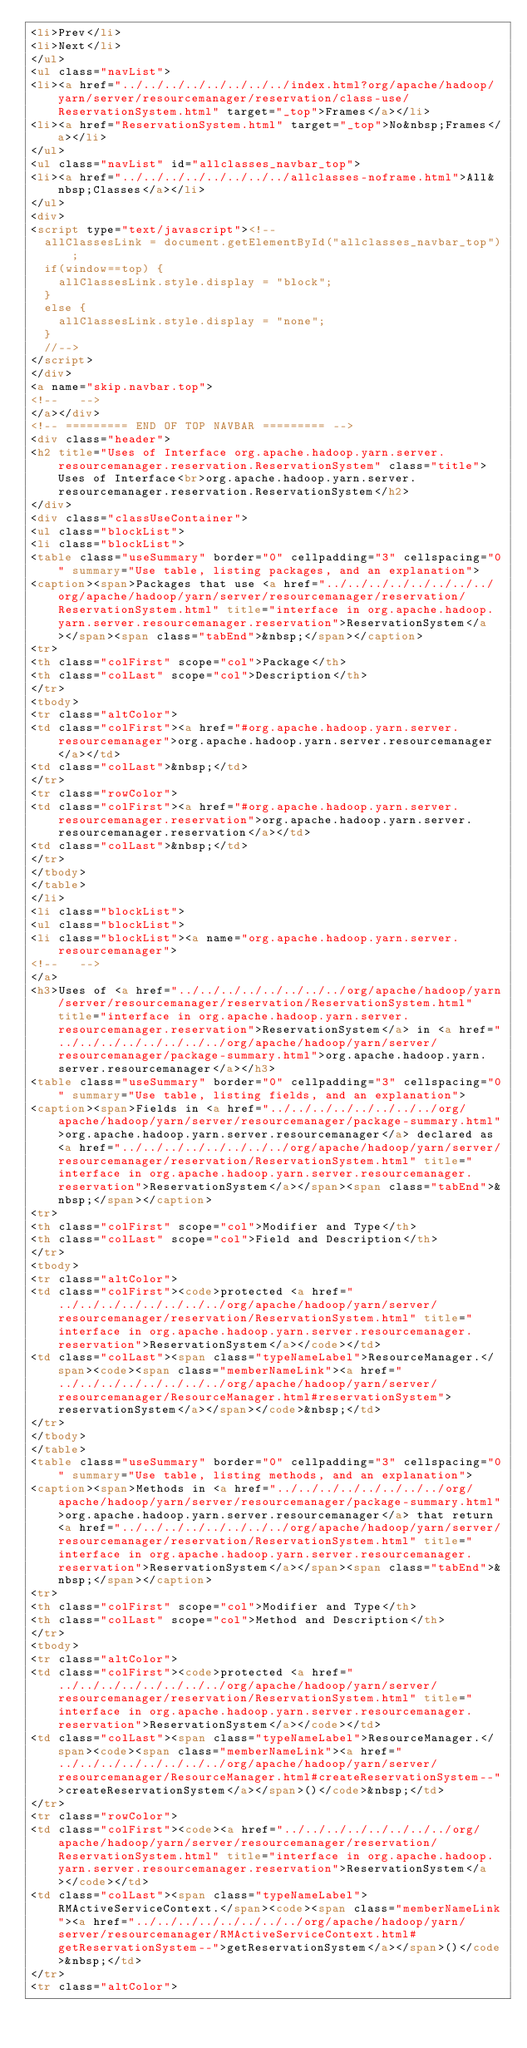<code> <loc_0><loc_0><loc_500><loc_500><_HTML_><li>Prev</li>
<li>Next</li>
</ul>
<ul class="navList">
<li><a href="../../../../../../../../index.html?org/apache/hadoop/yarn/server/resourcemanager/reservation/class-use/ReservationSystem.html" target="_top">Frames</a></li>
<li><a href="ReservationSystem.html" target="_top">No&nbsp;Frames</a></li>
</ul>
<ul class="navList" id="allclasses_navbar_top">
<li><a href="../../../../../../../../allclasses-noframe.html">All&nbsp;Classes</a></li>
</ul>
<div>
<script type="text/javascript"><!--
  allClassesLink = document.getElementById("allclasses_navbar_top");
  if(window==top) {
    allClassesLink.style.display = "block";
  }
  else {
    allClassesLink.style.display = "none";
  }
  //-->
</script>
</div>
<a name="skip.navbar.top">
<!--   -->
</a></div>
<!-- ========= END OF TOP NAVBAR ========= -->
<div class="header">
<h2 title="Uses of Interface org.apache.hadoop.yarn.server.resourcemanager.reservation.ReservationSystem" class="title">Uses of Interface<br>org.apache.hadoop.yarn.server.resourcemanager.reservation.ReservationSystem</h2>
</div>
<div class="classUseContainer">
<ul class="blockList">
<li class="blockList">
<table class="useSummary" border="0" cellpadding="3" cellspacing="0" summary="Use table, listing packages, and an explanation">
<caption><span>Packages that use <a href="../../../../../../../../org/apache/hadoop/yarn/server/resourcemanager/reservation/ReservationSystem.html" title="interface in org.apache.hadoop.yarn.server.resourcemanager.reservation">ReservationSystem</a></span><span class="tabEnd">&nbsp;</span></caption>
<tr>
<th class="colFirst" scope="col">Package</th>
<th class="colLast" scope="col">Description</th>
</tr>
<tbody>
<tr class="altColor">
<td class="colFirst"><a href="#org.apache.hadoop.yarn.server.resourcemanager">org.apache.hadoop.yarn.server.resourcemanager</a></td>
<td class="colLast">&nbsp;</td>
</tr>
<tr class="rowColor">
<td class="colFirst"><a href="#org.apache.hadoop.yarn.server.resourcemanager.reservation">org.apache.hadoop.yarn.server.resourcemanager.reservation</a></td>
<td class="colLast">&nbsp;</td>
</tr>
</tbody>
</table>
</li>
<li class="blockList">
<ul class="blockList">
<li class="blockList"><a name="org.apache.hadoop.yarn.server.resourcemanager">
<!--   -->
</a>
<h3>Uses of <a href="../../../../../../../../org/apache/hadoop/yarn/server/resourcemanager/reservation/ReservationSystem.html" title="interface in org.apache.hadoop.yarn.server.resourcemanager.reservation">ReservationSystem</a> in <a href="../../../../../../../../org/apache/hadoop/yarn/server/resourcemanager/package-summary.html">org.apache.hadoop.yarn.server.resourcemanager</a></h3>
<table class="useSummary" border="0" cellpadding="3" cellspacing="0" summary="Use table, listing fields, and an explanation">
<caption><span>Fields in <a href="../../../../../../../../org/apache/hadoop/yarn/server/resourcemanager/package-summary.html">org.apache.hadoop.yarn.server.resourcemanager</a> declared as <a href="../../../../../../../../org/apache/hadoop/yarn/server/resourcemanager/reservation/ReservationSystem.html" title="interface in org.apache.hadoop.yarn.server.resourcemanager.reservation">ReservationSystem</a></span><span class="tabEnd">&nbsp;</span></caption>
<tr>
<th class="colFirst" scope="col">Modifier and Type</th>
<th class="colLast" scope="col">Field and Description</th>
</tr>
<tbody>
<tr class="altColor">
<td class="colFirst"><code>protected <a href="../../../../../../../../org/apache/hadoop/yarn/server/resourcemanager/reservation/ReservationSystem.html" title="interface in org.apache.hadoop.yarn.server.resourcemanager.reservation">ReservationSystem</a></code></td>
<td class="colLast"><span class="typeNameLabel">ResourceManager.</span><code><span class="memberNameLink"><a href="../../../../../../../../org/apache/hadoop/yarn/server/resourcemanager/ResourceManager.html#reservationSystem">reservationSystem</a></span></code>&nbsp;</td>
</tr>
</tbody>
</table>
<table class="useSummary" border="0" cellpadding="3" cellspacing="0" summary="Use table, listing methods, and an explanation">
<caption><span>Methods in <a href="../../../../../../../../org/apache/hadoop/yarn/server/resourcemanager/package-summary.html">org.apache.hadoop.yarn.server.resourcemanager</a> that return <a href="../../../../../../../../org/apache/hadoop/yarn/server/resourcemanager/reservation/ReservationSystem.html" title="interface in org.apache.hadoop.yarn.server.resourcemanager.reservation">ReservationSystem</a></span><span class="tabEnd">&nbsp;</span></caption>
<tr>
<th class="colFirst" scope="col">Modifier and Type</th>
<th class="colLast" scope="col">Method and Description</th>
</tr>
<tbody>
<tr class="altColor">
<td class="colFirst"><code>protected <a href="../../../../../../../../org/apache/hadoop/yarn/server/resourcemanager/reservation/ReservationSystem.html" title="interface in org.apache.hadoop.yarn.server.resourcemanager.reservation">ReservationSystem</a></code></td>
<td class="colLast"><span class="typeNameLabel">ResourceManager.</span><code><span class="memberNameLink"><a href="../../../../../../../../org/apache/hadoop/yarn/server/resourcemanager/ResourceManager.html#createReservationSystem--">createReservationSystem</a></span>()</code>&nbsp;</td>
</tr>
<tr class="rowColor">
<td class="colFirst"><code><a href="../../../../../../../../org/apache/hadoop/yarn/server/resourcemanager/reservation/ReservationSystem.html" title="interface in org.apache.hadoop.yarn.server.resourcemanager.reservation">ReservationSystem</a></code></td>
<td class="colLast"><span class="typeNameLabel">RMActiveServiceContext.</span><code><span class="memberNameLink"><a href="../../../../../../../../org/apache/hadoop/yarn/server/resourcemanager/RMActiveServiceContext.html#getReservationSystem--">getReservationSystem</a></span>()</code>&nbsp;</td>
</tr>
<tr class="altColor"></code> 